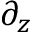<formula> <loc_0><loc_0><loc_500><loc_500>\partial _ { z }</formula> 